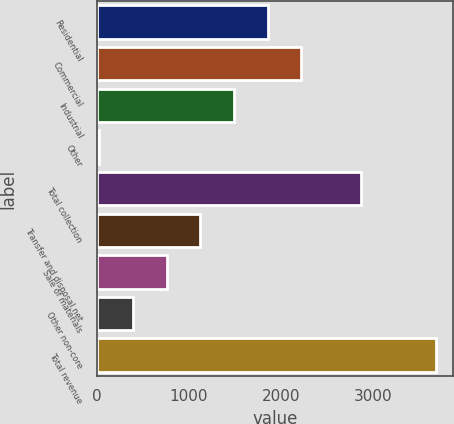<chart> <loc_0><loc_0><loc_500><loc_500><bar_chart><fcel>Residential<fcel>Commercial<fcel>Industrial<fcel>Other<fcel>Total collection<fcel>Transfer and disposal net<fcel>Sale of materials<fcel>Other non-core<fcel>Total revenue<nl><fcel>1854.15<fcel>2220.34<fcel>1487.96<fcel>23.2<fcel>2862<fcel>1121.77<fcel>755.58<fcel>389.39<fcel>3685.1<nl></chart> 